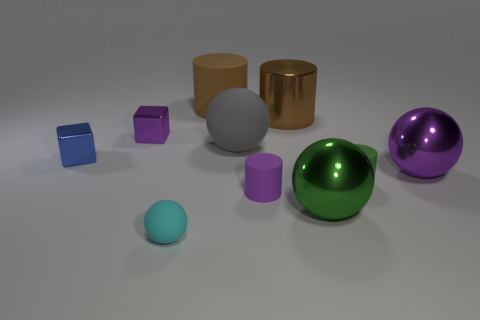Subtract 1 cylinders. How many cylinders are left? 3 Subtract all cylinders. How many objects are left? 6 Add 4 large cylinders. How many large cylinders are left? 6 Add 1 large gray rubber balls. How many large gray rubber balls exist? 2 Subtract 1 purple blocks. How many objects are left? 9 Subtract all rubber objects. Subtract all purple spheres. How many objects are left? 4 